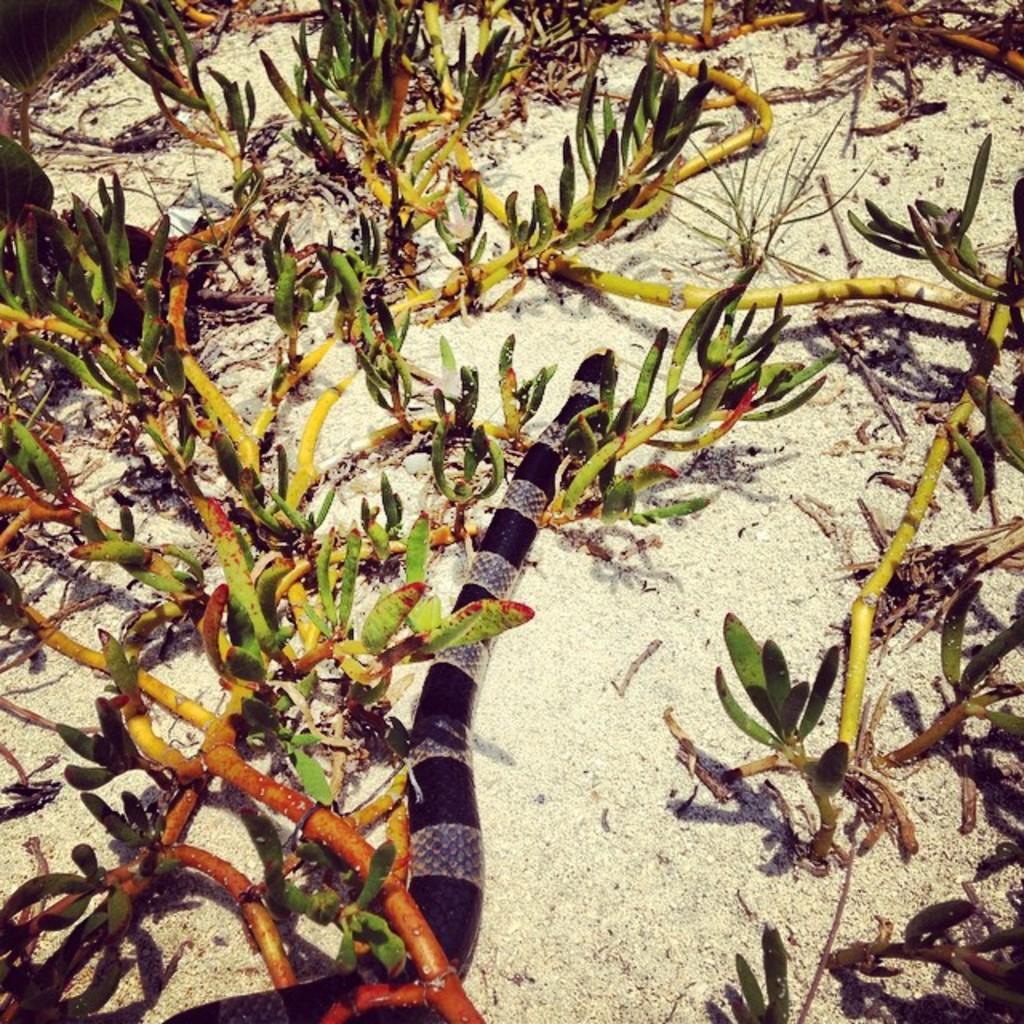Please provide a concise description of this image. This picture is clicked outside. In the center we can see the snake on the ground and we can see the branches, stems and the leaves and we can see some other objects. 